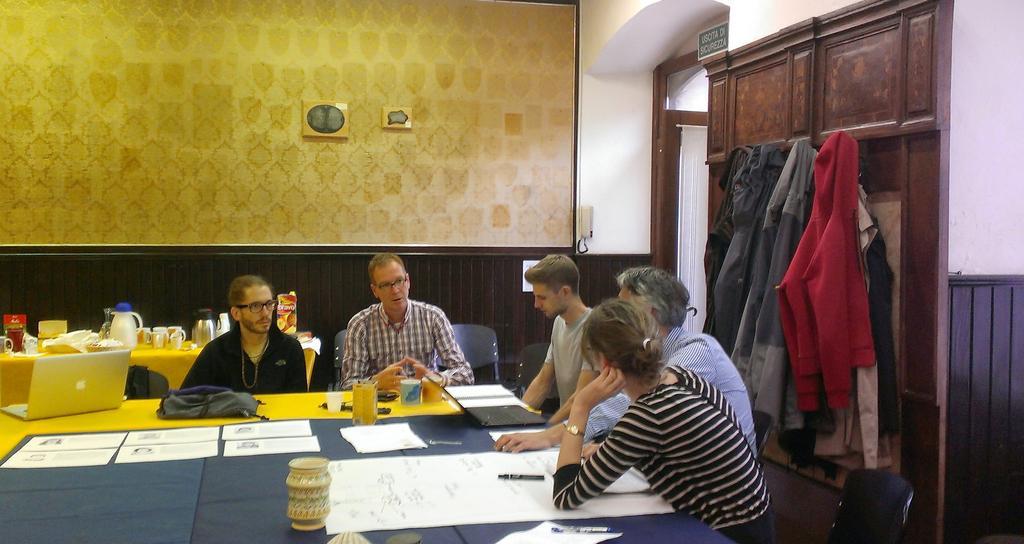Please provide a concise description of this image. There are five members sitting around a table. On the table there are some accessories along with a glasses and laptop. Behind them there is a table on which some jars and glasses were placed. And we can observe a wall in the background. 